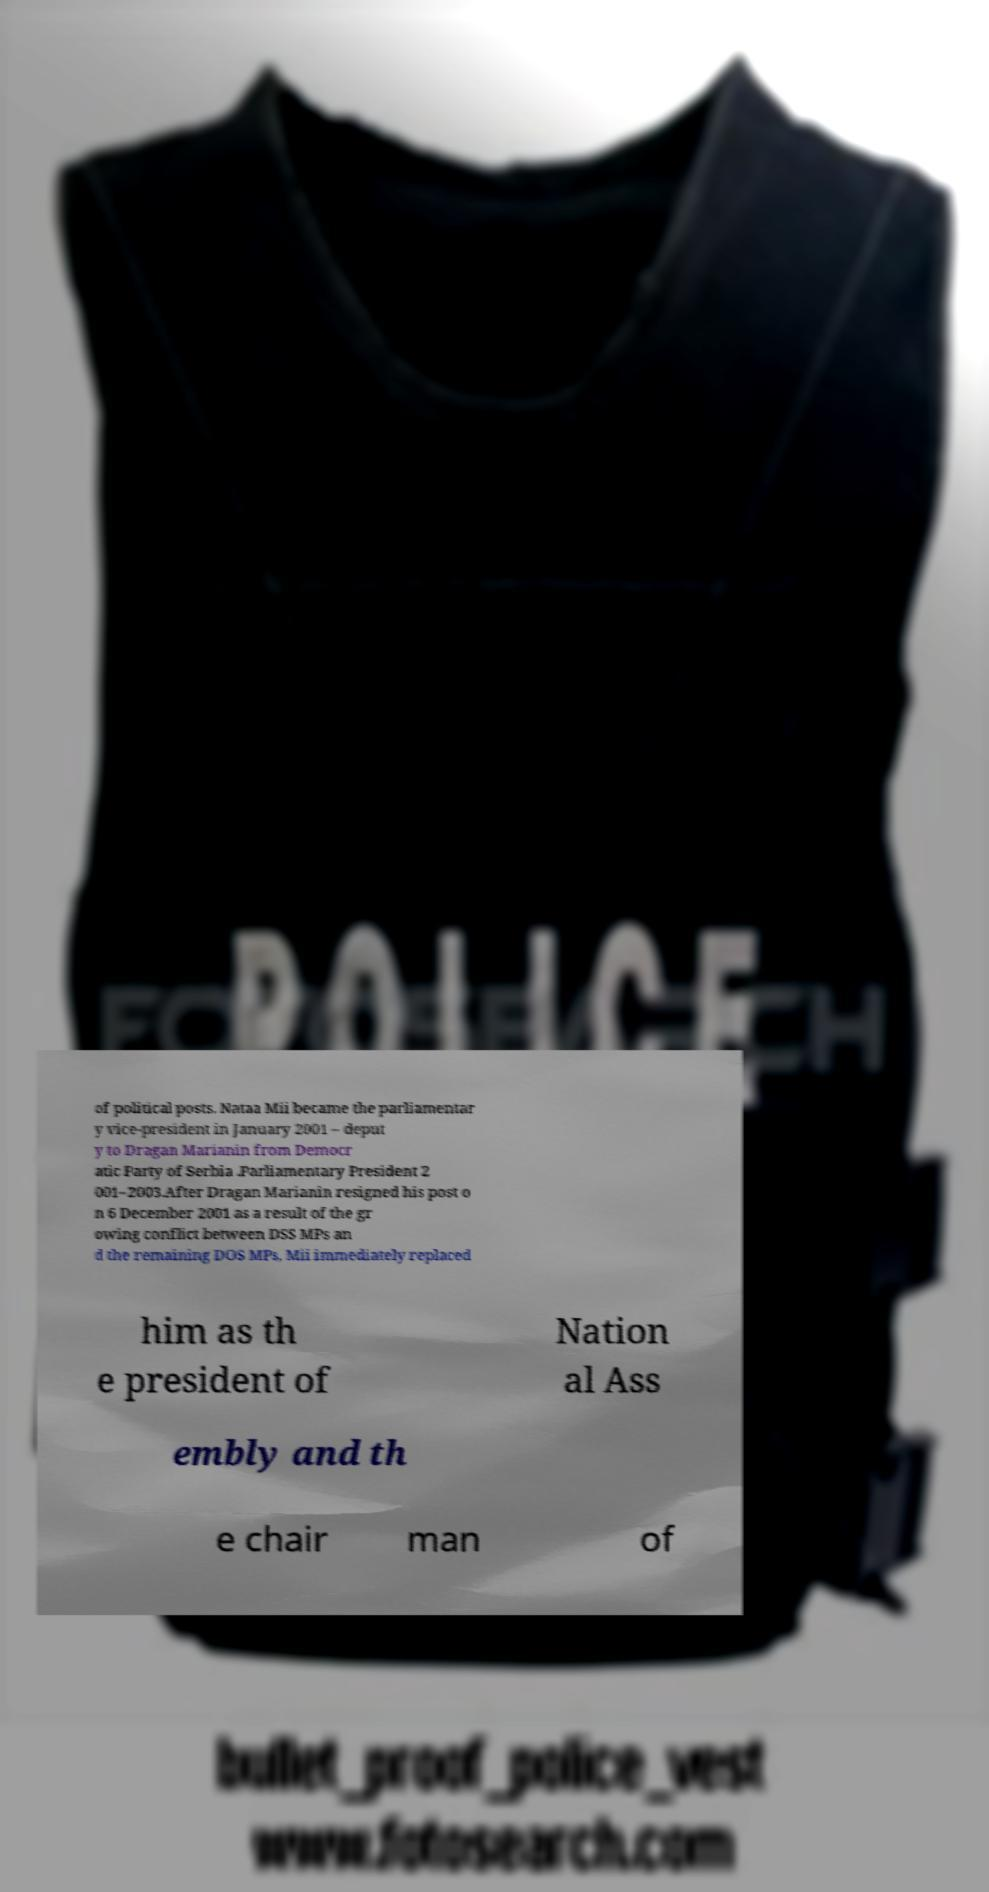There's text embedded in this image that I need extracted. Can you transcribe it verbatim? of political posts. Nataa Mii became the parliamentar y vice-president in January 2001 – deput y to Dragan Marianin from Democr atic Party of Serbia .Parliamentary President 2 001–2003.After Dragan Marianin resigned his post o n 6 December 2001 as a result of the gr owing conflict between DSS MPs an d the remaining DOS MPs, Mii immediately replaced him as th e president of Nation al Ass embly and th e chair man of 